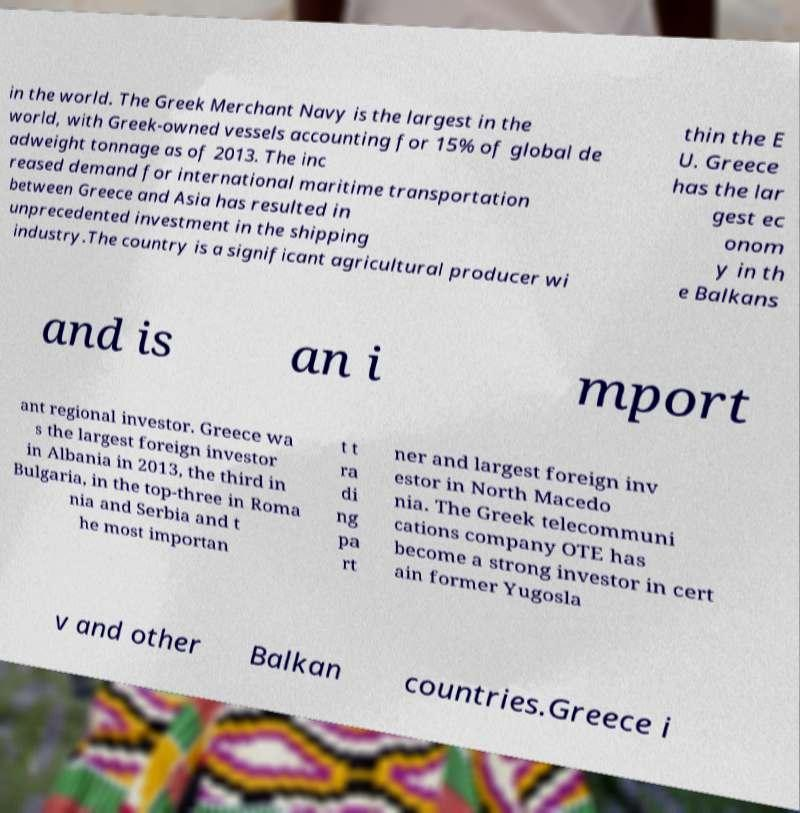Can you accurately transcribe the text from the provided image for me? in the world. The Greek Merchant Navy is the largest in the world, with Greek-owned vessels accounting for 15% of global de adweight tonnage as of 2013. The inc reased demand for international maritime transportation between Greece and Asia has resulted in unprecedented investment in the shipping industry.The country is a significant agricultural producer wi thin the E U. Greece has the lar gest ec onom y in th e Balkans and is an i mport ant regional investor. Greece wa s the largest foreign investor in Albania in 2013, the third in Bulgaria, in the top-three in Roma nia and Serbia and t he most importan t t ra di ng pa rt ner and largest foreign inv estor in North Macedo nia. The Greek telecommuni cations company OTE has become a strong investor in cert ain former Yugosla v and other Balkan countries.Greece i 